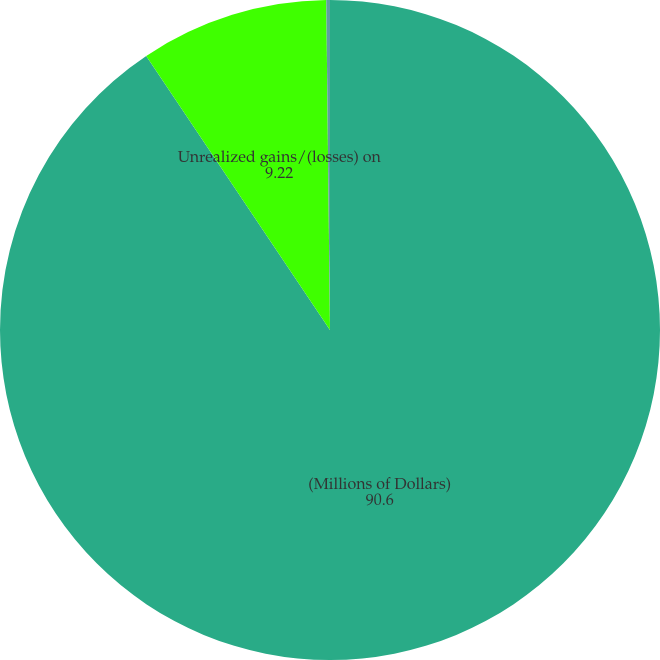Convert chart to OTSL. <chart><loc_0><loc_0><loc_500><loc_500><pie_chart><fcel>(Millions of Dollars)<fcel>Unrealized gains/(losses) on<fcel>Less Reclassification<nl><fcel>90.6%<fcel>9.22%<fcel>0.18%<nl></chart> 